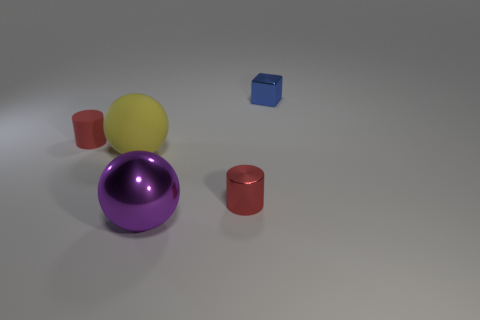Add 5 tiny metallic objects. How many objects exist? 10 Subtract all blocks. How many objects are left? 4 Subtract 2 balls. How many balls are left? 0 Add 5 big purple matte objects. How many big purple matte objects exist? 5 Subtract all purple balls. How many balls are left? 1 Subtract 0 blue spheres. How many objects are left? 5 Subtract all purple spheres. Subtract all brown cylinders. How many spheres are left? 1 Subtract all blue cylinders. How many purple spheres are left? 1 Subtract all tiny blue objects. Subtract all cyan shiny blocks. How many objects are left? 4 Add 2 large purple shiny things. How many large purple shiny things are left? 3 